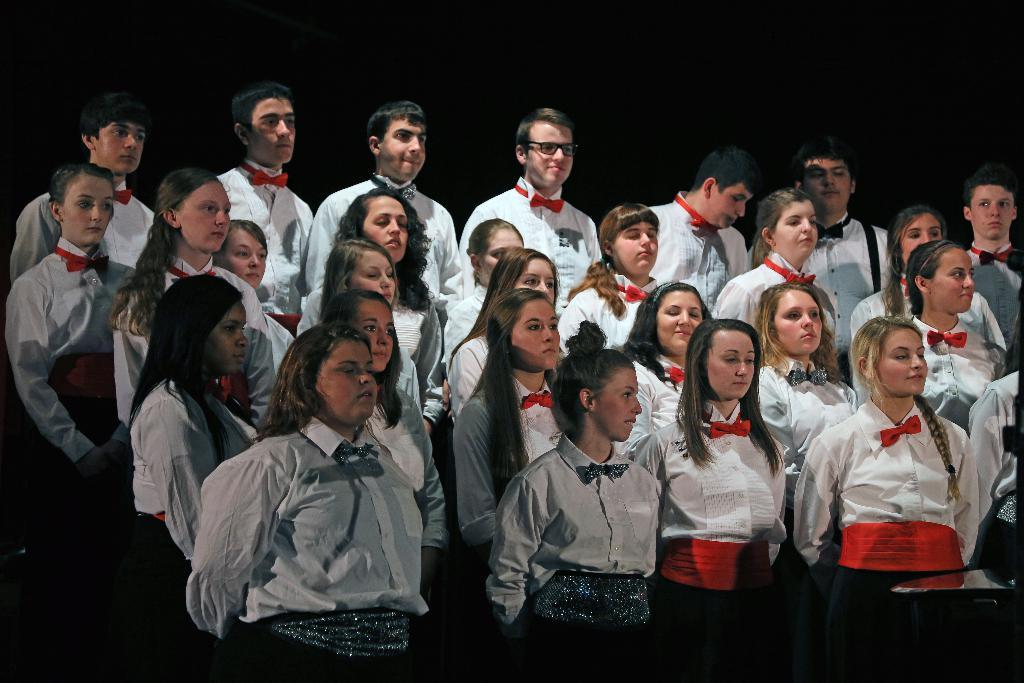What is the main subject of the image? The main subject of the image is a group of people. What are the people in the image doing? The people are standing. What are the people wearing in the image? The people are wearing the same color dress. What can be seen in the background of the image? The background of the image is dark. What type of quince can be seen in the hands of the people in the image? There is no quince present in the image; the people are wearing the same color dress and standing. How many wrens can be seen perched on the shoulders of the people in the image? There are no wrens present in the image; the focus is on the group of people standing and wearing the same color dress. 